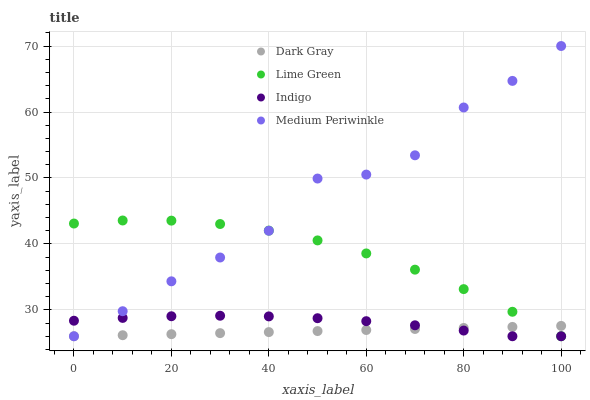Does Dark Gray have the minimum area under the curve?
Answer yes or no. Yes. Does Medium Periwinkle have the maximum area under the curve?
Answer yes or no. Yes. Does Indigo have the minimum area under the curve?
Answer yes or no. No. Does Indigo have the maximum area under the curve?
Answer yes or no. No. Is Dark Gray the smoothest?
Answer yes or no. Yes. Is Medium Periwinkle the roughest?
Answer yes or no. Yes. Is Indigo the smoothest?
Answer yes or no. No. Is Indigo the roughest?
Answer yes or no. No. Does Dark Gray have the lowest value?
Answer yes or no. Yes. Does Medium Periwinkle have the highest value?
Answer yes or no. Yes. Does Indigo have the highest value?
Answer yes or no. No. Does Medium Periwinkle intersect Indigo?
Answer yes or no. Yes. Is Medium Periwinkle less than Indigo?
Answer yes or no. No. Is Medium Periwinkle greater than Indigo?
Answer yes or no. No. 